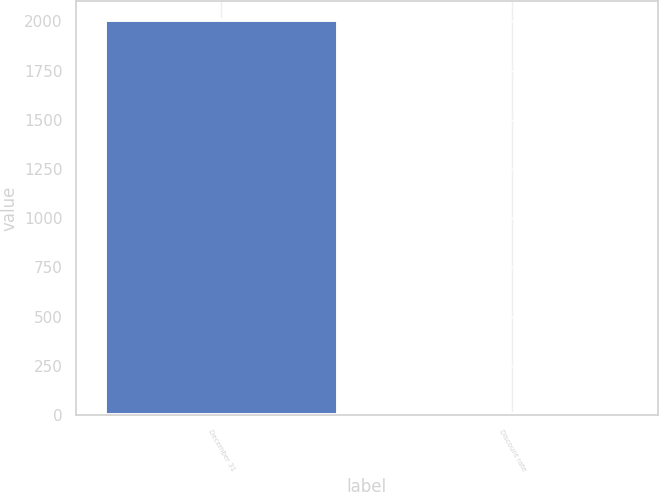Convert chart. <chart><loc_0><loc_0><loc_500><loc_500><bar_chart><fcel>December 31<fcel>Discount rate<nl><fcel>2004<fcel>5.9<nl></chart> 